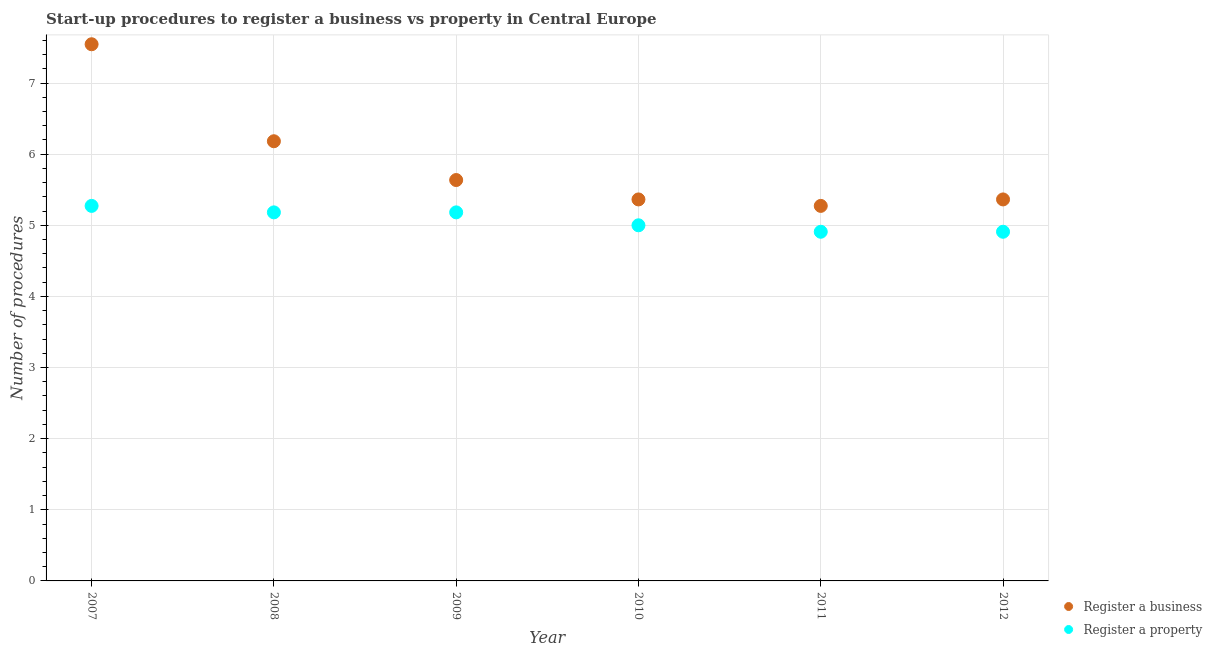What is the number of procedures to register a business in 2012?
Make the answer very short. 5.36. Across all years, what is the maximum number of procedures to register a property?
Your answer should be very brief. 5.27. Across all years, what is the minimum number of procedures to register a property?
Offer a terse response. 4.91. In which year was the number of procedures to register a business minimum?
Offer a terse response. 2011. What is the total number of procedures to register a property in the graph?
Your answer should be very brief. 30.45. What is the difference between the number of procedures to register a property in 2007 and that in 2010?
Keep it short and to the point. 0.27. What is the difference between the number of procedures to register a business in 2011 and the number of procedures to register a property in 2010?
Your answer should be compact. 0.27. What is the average number of procedures to register a property per year?
Offer a very short reply. 5.08. In the year 2009, what is the difference between the number of procedures to register a business and number of procedures to register a property?
Provide a short and direct response. 0.45. In how many years, is the number of procedures to register a property greater than 3.4?
Make the answer very short. 6. What is the difference between the highest and the second highest number of procedures to register a business?
Ensure brevity in your answer.  1.36. What is the difference between the highest and the lowest number of procedures to register a business?
Ensure brevity in your answer.  2.27. Does the number of procedures to register a property monotonically increase over the years?
Provide a short and direct response. No. Is the number of procedures to register a property strictly greater than the number of procedures to register a business over the years?
Offer a terse response. No. Is the number of procedures to register a property strictly less than the number of procedures to register a business over the years?
Give a very brief answer. Yes. How many dotlines are there?
Give a very brief answer. 2. What is the difference between two consecutive major ticks on the Y-axis?
Ensure brevity in your answer.  1. Are the values on the major ticks of Y-axis written in scientific E-notation?
Make the answer very short. No. Does the graph contain any zero values?
Your answer should be very brief. No. Where does the legend appear in the graph?
Give a very brief answer. Bottom right. How many legend labels are there?
Offer a terse response. 2. How are the legend labels stacked?
Ensure brevity in your answer.  Vertical. What is the title of the graph?
Offer a very short reply. Start-up procedures to register a business vs property in Central Europe. What is the label or title of the X-axis?
Keep it short and to the point. Year. What is the label or title of the Y-axis?
Make the answer very short. Number of procedures. What is the Number of procedures of Register a business in 2007?
Your answer should be very brief. 7.55. What is the Number of procedures of Register a property in 2007?
Make the answer very short. 5.27. What is the Number of procedures of Register a business in 2008?
Your answer should be compact. 6.18. What is the Number of procedures in Register a property in 2008?
Provide a short and direct response. 5.18. What is the Number of procedures in Register a business in 2009?
Make the answer very short. 5.64. What is the Number of procedures in Register a property in 2009?
Give a very brief answer. 5.18. What is the Number of procedures in Register a business in 2010?
Keep it short and to the point. 5.36. What is the Number of procedures in Register a property in 2010?
Provide a short and direct response. 5. What is the Number of procedures in Register a business in 2011?
Your answer should be compact. 5.27. What is the Number of procedures in Register a property in 2011?
Offer a very short reply. 4.91. What is the Number of procedures in Register a business in 2012?
Ensure brevity in your answer.  5.36. What is the Number of procedures in Register a property in 2012?
Provide a succinct answer. 4.91. Across all years, what is the maximum Number of procedures of Register a business?
Your response must be concise. 7.55. Across all years, what is the maximum Number of procedures of Register a property?
Provide a short and direct response. 5.27. Across all years, what is the minimum Number of procedures in Register a business?
Your answer should be compact. 5.27. Across all years, what is the minimum Number of procedures of Register a property?
Your answer should be compact. 4.91. What is the total Number of procedures in Register a business in the graph?
Offer a terse response. 35.36. What is the total Number of procedures in Register a property in the graph?
Provide a short and direct response. 30.45. What is the difference between the Number of procedures of Register a business in 2007 and that in 2008?
Keep it short and to the point. 1.36. What is the difference between the Number of procedures in Register a property in 2007 and that in 2008?
Provide a short and direct response. 0.09. What is the difference between the Number of procedures of Register a business in 2007 and that in 2009?
Offer a terse response. 1.91. What is the difference between the Number of procedures of Register a property in 2007 and that in 2009?
Ensure brevity in your answer.  0.09. What is the difference between the Number of procedures of Register a business in 2007 and that in 2010?
Offer a very short reply. 2.18. What is the difference between the Number of procedures in Register a property in 2007 and that in 2010?
Your response must be concise. 0.27. What is the difference between the Number of procedures in Register a business in 2007 and that in 2011?
Make the answer very short. 2.27. What is the difference between the Number of procedures of Register a property in 2007 and that in 2011?
Provide a short and direct response. 0.36. What is the difference between the Number of procedures of Register a business in 2007 and that in 2012?
Offer a terse response. 2.18. What is the difference between the Number of procedures of Register a property in 2007 and that in 2012?
Give a very brief answer. 0.36. What is the difference between the Number of procedures in Register a business in 2008 and that in 2009?
Provide a succinct answer. 0.55. What is the difference between the Number of procedures in Register a property in 2008 and that in 2009?
Your response must be concise. 0. What is the difference between the Number of procedures in Register a business in 2008 and that in 2010?
Ensure brevity in your answer.  0.82. What is the difference between the Number of procedures of Register a property in 2008 and that in 2010?
Give a very brief answer. 0.18. What is the difference between the Number of procedures of Register a business in 2008 and that in 2011?
Make the answer very short. 0.91. What is the difference between the Number of procedures in Register a property in 2008 and that in 2011?
Give a very brief answer. 0.27. What is the difference between the Number of procedures of Register a business in 2008 and that in 2012?
Your response must be concise. 0.82. What is the difference between the Number of procedures in Register a property in 2008 and that in 2012?
Make the answer very short. 0.27. What is the difference between the Number of procedures of Register a business in 2009 and that in 2010?
Your response must be concise. 0.27. What is the difference between the Number of procedures in Register a property in 2009 and that in 2010?
Provide a succinct answer. 0.18. What is the difference between the Number of procedures in Register a business in 2009 and that in 2011?
Your answer should be compact. 0.36. What is the difference between the Number of procedures in Register a property in 2009 and that in 2011?
Your answer should be very brief. 0.27. What is the difference between the Number of procedures of Register a business in 2009 and that in 2012?
Your response must be concise. 0.27. What is the difference between the Number of procedures in Register a property in 2009 and that in 2012?
Offer a terse response. 0.27. What is the difference between the Number of procedures in Register a business in 2010 and that in 2011?
Provide a short and direct response. 0.09. What is the difference between the Number of procedures of Register a property in 2010 and that in 2011?
Keep it short and to the point. 0.09. What is the difference between the Number of procedures in Register a business in 2010 and that in 2012?
Your answer should be compact. 0. What is the difference between the Number of procedures in Register a property in 2010 and that in 2012?
Provide a succinct answer. 0.09. What is the difference between the Number of procedures of Register a business in 2011 and that in 2012?
Provide a succinct answer. -0.09. What is the difference between the Number of procedures in Register a business in 2007 and the Number of procedures in Register a property in 2008?
Keep it short and to the point. 2.36. What is the difference between the Number of procedures in Register a business in 2007 and the Number of procedures in Register a property in 2009?
Keep it short and to the point. 2.36. What is the difference between the Number of procedures in Register a business in 2007 and the Number of procedures in Register a property in 2010?
Your answer should be compact. 2.55. What is the difference between the Number of procedures of Register a business in 2007 and the Number of procedures of Register a property in 2011?
Your response must be concise. 2.64. What is the difference between the Number of procedures of Register a business in 2007 and the Number of procedures of Register a property in 2012?
Offer a very short reply. 2.64. What is the difference between the Number of procedures of Register a business in 2008 and the Number of procedures of Register a property in 2009?
Your answer should be compact. 1. What is the difference between the Number of procedures of Register a business in 2008 and the Number of procedures of Register a property in 2010?
Your response must be concise. 1.18. What is the difference between the Number of procedures of Register a business in 2008 and the Number of procedures of Register a property in 2011?
Provide a succinct answer. 1.27. What is the difference between the Number of procedures in Register a business in 2008 and the Number of procedures in Register a property in 2012?
Your answer should be very brief. 1.27. What is the difference between the Number of procedures in Register a business in 2009 and the Number of procedures in Register a property in 2010?
Offer a very short reply. 0.64. What is the difference between the Number of procedures in Register a business in 2009 and the Number of procedures in Register a property in 2011?
Offer a terse response. 0.73. What is the difference between the Number of procedures in Register a business in 2009 and the Number of procedures in Register a property in 2012?
Provide a succinct answer. 0.73. What is the difference between the Number of procedures of Register a business in 2010 and the Number of procedures of Register a property in 2011?
Give a very brief answer. 0.45. What is the difference between the Number of procedures of Register a business in 2010 and the Number of procedures of Register a property in 2012?
Give a very brief answer. 0.45. What is the difference between the Number of procedures in Register a business in 2011 and the Number of procedures in Register a property in 2012?
Give a very brief answer. 0.36. What is the average Number of procedures in Register a business per year?
Give a very brief answer. 5.89. What is the average Number of procedures in Register a property per year?
Offer a terse response. 5.08. In the year 2007, what is the difference between the Number of procedures in Register a business and Number of procedures in Register a property?
Your response must be concise. 2.27. In the year 2008, what is the difference between the Number of procedures of Register a business and Number of procedures of Register a property?
Provide a succinct answer. 1. In the year 2009, what is the difference between the Number of procedures in Register a business and Number of procedures in Register a property?
Your response must be concise. 0.45. In the year 2010, what is the difference between the Number of procedures of Register a business and Number of procedures of Register a property?
Offer a very short reply. 0.36. In the year 2011, what is the difference between the Number of procedures of Register a business and Number of procedures of Register a property?
Your answer should be compact. 0.36. In the year 2012, what is the difference between the Number of procedures in Register a business and Number of procedures in Register a property?
Make the answer very short. 0.45. What is the ratio of the Number of procedures in Register a business in 2007 to that in 2008?
Make the answer very short. 1.22. What is the ratio of the Number of procedures in Register a property in 2007 to that in 2008?
Provide a succinct answer. 1.02. What is the ratio of the Number of procedures in Register a business in 2007 to that in 2009?
Give a very brief answer. 1.34. What is the ratio of the Number of procedures in Register a property in 2007 to that in 2009?
Your answer should be very brief. 1.02. What is the ratio of the Number of procedures in Register a business in 2007 to that in 2010?
Your response must be concise. 1.41. What is the ratio of the Number of procedures in Register a property in 2007 to that in 2010?
Your response must be concise. 1.05. What is the ratio of the Number of procedures of Register a business in 2007 to that in 2011?
Offer a very short reply. 1.43. What is the ratio of the Number of procedures of Register a property in 2007 to that in 2011?
Your response must be concise. 1.07. What is the ratio of the Number of procedures in Register a business in 2007 to that in 2012?
Keep it short and to the point. 1.41. What is the ratio of the Number of procedures of Register a property in 2007 to that in 2012?
Make the answer very short. 1.07. What is the ratio of the Number of procedures of Register a business in 2008 to that in 2009?
Ensure brevity in your answer.  1.1. What is the ratio of the Number of procedures of Register a business in 2008 to that in 2010?
Offer a very short reply. 1.15. What is the ratio of the Number of procedures in Register a property in 2008 to that in 2010?
Offer a terse response. 1.04. What is the ratio of the Number of procedures in Register a business in 2008 to that in 2011?
Provide a short and direct response. 1.17. What is the ratio of the Number of procedures of Register a property in 2008 to that in 2011?
Keep it short and to the point. 1.06. What is the ratio of the Number of procedures in Register a business in 2008 to that in 2012?
Your answer should be compact. 1.15. What is the ratio of the Number of procedures in Register a property in 2008 to that in 2012?
Make the answer very short. 1.06. What is the ratio of the Number of procedures in Register a business in 2009 to that in 2010?
Your answer should be very brief. 1.05. What is the ratio of the Number of procedures of Register a property in 2009 to that in 2010?
Keep it short and to the point. 1.04. What is the ratio of the Number of procedures in Register a business in 2009 to that in 2011?
Your answer should be compact. 1.07. What is the ratio of the Number of procedures of Register a property in 2009 to that in 2011?
Offer a very short reply. 1.06. What is the ratio of the Number of procedures of Register a business in 2009 to that in 2012?
Your response must be concise. 1.05. What is the ratio of the Number of procedures in Register a property in 2009 to that in 2012?
Ensure brevity in your answer.  1.06. What is the ratio of the Number of procedures in Register a business in 2010 to that in 2011?
Your answer should be very brief. 1.02. What is the ratio of the Number of procedures of Register a property in 2010 to that in 2011?
Give a very brief answer. 1.02. What is the ratio of the Number of procedures in Register a business in 2010 to that in 2012?
Provide a succinct answer. 1. What is the ratio of the Number of procedures of Register a property in 2010 to that in 2012?
Give a very brief answer. 1.02. What is the ratio of the Number of procedures of Register a business in 2011 to that in 2012?
Offer a very short reply. 0.98. What is the difference between the highest and the second highest Number of procedures of Register a business?
Your answer should be compact. 1.36. What is the difference between the highest and the second highest Number of procedures in Register a property?
Provide a succinct answer. 0.09. What is the difference between the highest and the lowest Number of procedures in Register a business?
Keep it short and to the point. 2.27. What is the difference between the highest and the lowest Number of procedures of Register a property?
Ensure brevity in your answer.  0.36. 